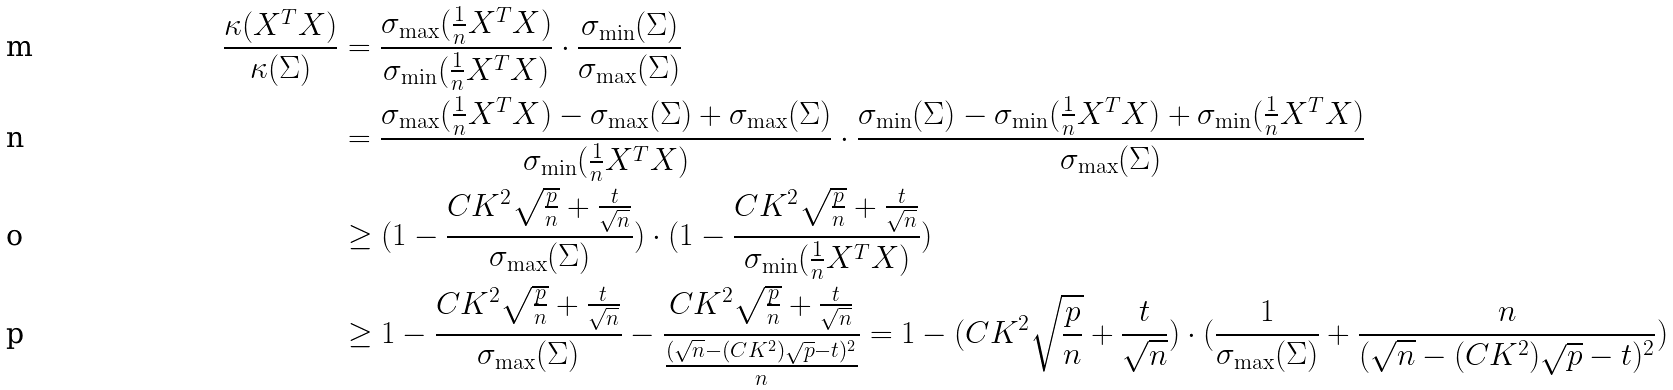Convert formula to latex. <formula><loc_0><loc_0><loc_500><loc_500>\frac { \kappa ( X ^ { T } X ) } { \kappa ( \Sigma ) } & = \frac { \sigma _ { \max } ( \frac { 1 } { n } X ^ { T } X ) } { \sigma _ { \min } ( \frac { 1 } { n } X ^ { T } X ) } \cdot \frac { \sigma _ { \min } ( \Sigma ) } { \sigma _ { \max } ( \Sigma ) } \\ & = \frac { \sigma _ { \max } ( \frac { 1 } { n } X ^ { T } X ) - \sigma _ { \max } ( \Sigma ) + \sigma _ { \max } ( \Sigma ) } { \sigma _ { \min } ( \frac { 1 } { n } X ^ { T } X ) } \cdot \frac { \sigma _ { \min } ( \Sigma ) - \sigma _ { \min } ( \frac { 1 } { n } X ^ { T } X ) + \sigma _ { \min } ( \frac { 1 } { n } X ^ { T } X ) } { \sigma _ { \max } ( \Sigma ) } \\ & \geq ( 1 - \frac { C K ^ { 2 } \sqrt { \frac { p } { n } } + \frac { t } { \sqrt { n } } } { \sigma _ { \max } ( \Sigma ) } ) \cdot ( 1 - \frac { C K ^ { 2 } \sqrt { \frac { p } { n } } + \frac { t } { \sqrt { n } } } { \sigma _ { \min } ( \frac { 1 } { n } X ^ { T } X ) } ) \\ & \geq 1 - \frac { C K ^ { 2 } \sqrt { \frac { p } { n } } + \frac { t } { \sqrt { n } } } { \sigma _ { \max } ( \Sigma ) } - \frac { C K ^ { 2 } \sqrt { \frac { p } { n } } + \frac { t } { \sqrt { n } } } { \frac { ( \sqrt { n } - ( C K ^ { 2 } ) \sqrt { p } - t ) ^ { 2 } } { n } } = 1 - ( C K ^ { 2 } \sqrt { \frac { p } { n } } + \frac { t } { \sqrt { n } } ) \cdot ( \frac { 1 } { \sigma _ { \max } ( \Sigma ) } + \frac { n } { ( \sqrt { n } - ( C K ^ { 2 } ) \sqrt { p } - t ) ^ { 2 } } )</formula> 